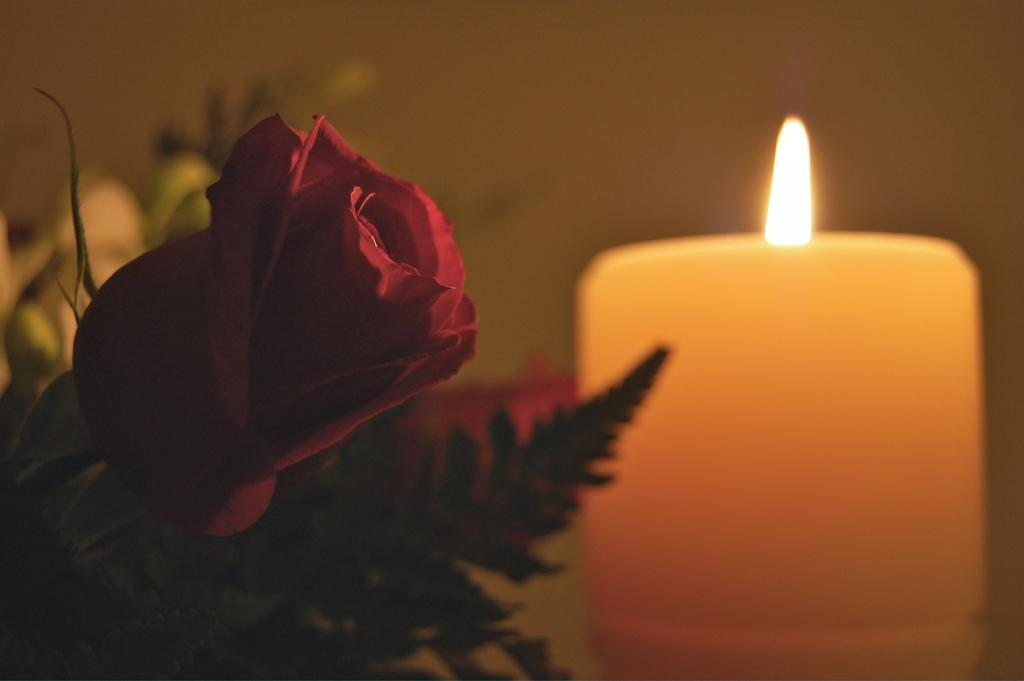What type of plant is depicted on the left side of the image? There is a flower and leaves on the left side of the image. What is the source of light on the right side of the image? There is a candle with a flame on the right side of the image. How would you describe the background of the image? The background of the image is blurred. Can you identify any objects in the background of the image? Yes, objects are visible in the background of the image. What type of shoes can be seen in the image? There are no shoes present in the image. What type of boundary is depicted in the image? There is no boundary depicted in the image. 